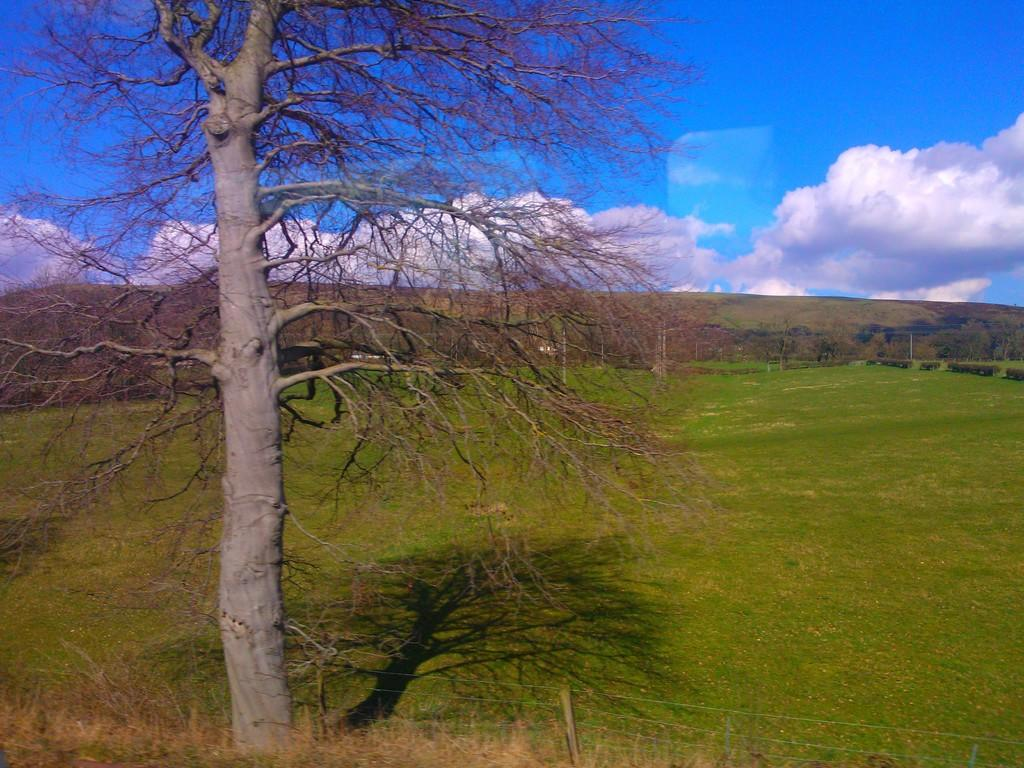What is located in the foreground of the image? There is a tree and a fence in the foreground of the image. What can be seen in the background of the image? Mountains are visible in the background of the image. What is visible at the top of the image? The sky is visible at the top of the image. When was the image taken? The image was taken during the day. From where was the image taken? The image was taken from the ground. What type of authority figure can be seen in the image? There is no authority figure present in the image. What type of utensil is used to eat the mountains in the image? There are no utensils or mountains being eaten in the image. Is there a jail visible in the image? There is no jail present in the image. 